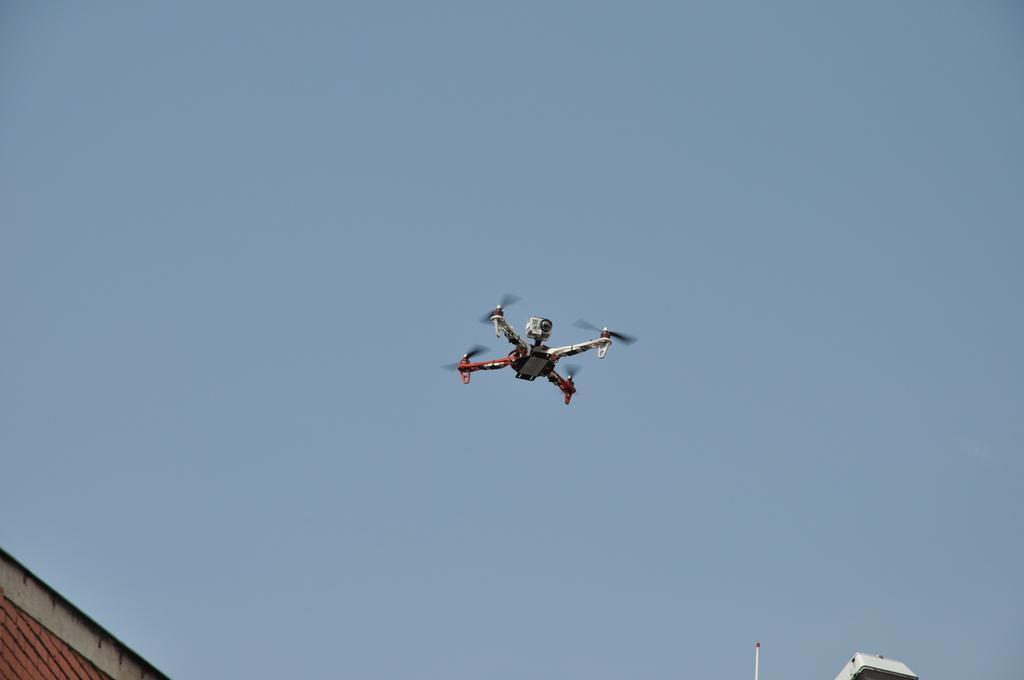How would you summarize this image in a sentence or two? In the middle of this image, there is a drone camera which is having four fans in the air. On the left side, there is a roof. On the right side, there is an object. In the background, there is blue sky. 